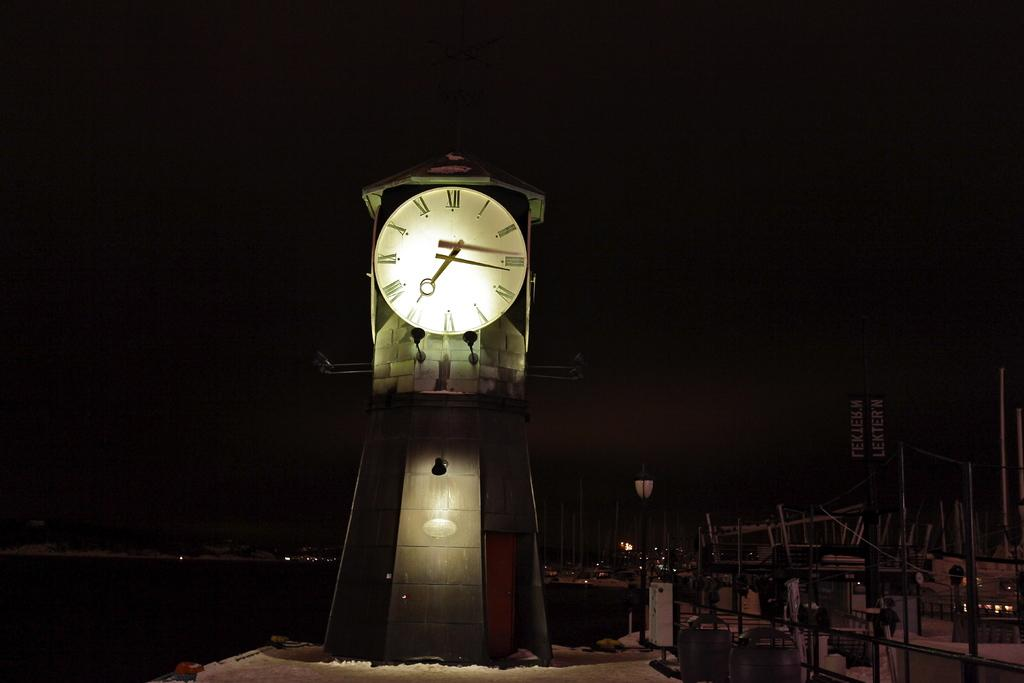<image>
Present a compact description of the photo's key features. The clock reads 7:14 on a dark, snowy night 